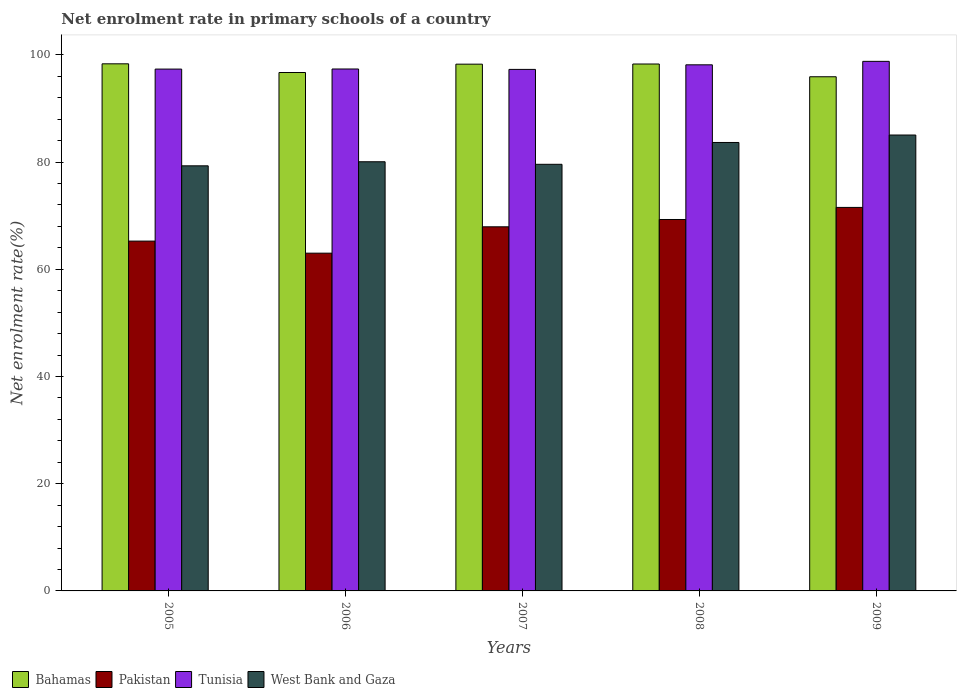How many different coloured bars are there?
Your answer should be very brief. 4. Are the number of bars per tick equal to the number of legend labels?
Offer a very short reply. Yes. How many bars are there on the 1st tick from the left?
Provide a succinct answer. 4. In how many cases, is the number of bars for a given year not equal to the number of legend labels?
Your answer should be compact. 0. What is the net enrolment rate in primary schools in Pakistan in 2005?
Offer a very short reply. 65.26. Across all years, what is the maximum net enrolment rate in primary schools in Bahamas?
Make the answer very short. 98.34. Across all years, what is the minimum net enrolment rate in primary schools in Pakistan?
Your response must be concise. 63.01. In which year was the net enrolment rate in primary schools in Pakistan minimum?
Provide a succinct answer. 2006. What is the total net enrolment rate in primary schools in Pakistan in the graph?
Make the answer very short. 337.05. What is the difference between the net enrolment rate in primary schools in West Bank and Gaza in 2006 and that in 2008?
Your answer should be very brief. -3.6. What is the difference between the net enrolment rate in primary schools in Pakistan in 2009 and the net enrolment rate in primary schools in West Bank and Gaza in 2006?
Your response must be concise. -8.52. What is the average net enrolment rate in primary schools in Bahamas per year?
Provide a succinct answer. 97.51. In the year 2008, what is the difference between the net enrolment rate in primary schools in West Bank and Gaza and net enrolment rate in primary schools in Tunisia?
Provide a short and direct response. -14.49. In how many years, is the net enrolment rate in primary schools in Pakistan greater than 24 %?
Your answer should be compact. 5. What is the ratio of the net enrolment rate in primary schools in Tunisia in 2005 to that in 2009?
Offer a very short reply. 0.99. What is the difference between the highest and the second highest net enrolment rate in primary schools in Pakistan?
Your response must be concise. 2.25. What is the difference between the highest and the lowest net enrolment rate in primary schools in West Bank and Gaza?
Your response must be concise. 5.75. In how many years, is the net enrolment rate in primary schools in West Bank and Gaza greater than the average net enrolment rate in primary schools in West Bank and Gaza taken over all years?
Provide a short and direct response. 2. Is the sum of the net enrolment rate in primary schools in Pakistan in 2006 and 2008 greater than the maximum net enrolment rate in primary schools in Tunisia across all years?
Your answer should be very brief. Yes. Is it the case that in every year, the sum of the net enrolment rate in primary schools in Tunisia and net enrolment rate in primary schools in Bahamas is greater than the sum of net enrolment rate in primary schools in West Bank and Gaza and net enrolment rate in primary schools in Pakistan?
Your response must be concise. No. What does the 3rd bar from the left in 2005 represents?
Your answer should be very brief. Tunisia. What does the 1st bar from the right in 2009 represents?
Give a very brief answer. West Bank and Gaza. Is it the case that in every year, the sum of the net enrolment rate in primary schools in Pakistan and net enrolment rate in primary schools in Bahamas is greater than the net enrolment rate in primary schools in Tunisia?
Your answer should be compact. Yes. How many years are there in the graph?
Your answer should be very brief. 5. Are the values on the major ticks of Y-axis written in scientific E-notation?
Keep it short and to the point. No. Does the graph contain any zero values?
Provide a short and direct response. No. What is the title of the graph?
Provide a succinct answer. Net enrolment rate in primary schools of a country. Does "Bulgaria" appear as one of the legend labels in the graph?
Your response must be concise. No. What is the label or title of the Y-axis?
Your answer should be compact. Net enrolment rate(%). What is the Net enrolment rate(%) in Bahamas in 2005?
Your answer should be compact. 98.34. What is the Net enrolment rate(%) of Pakistan in 2005?
Provide a succinct answer. 65.26. What is the Net enrolment rate(%) in Tunisia in 2005?
Your answer should be compact. 97.35. What is the Net enrolment rate(%) in West Bank and Gaza in 2005?
Give a very brief answer. 79.31. What is the Net enrolment rate(%) in Bahamas in 2006?
Give a very brief answer. 96.72. What is the Net enrolment rate(%) in Pakistan in 2006?
Your answer should be compact. 63.01. What is the Net enrolment rate(%) of Tunisia in 2006?
Your response must be concise. 97.37. What is the Net enrolment rate(%) in West Bank and Gaza in 2006?
Your answer should be compact. 80.07. What is the Net enrolment rate(%) in Bahamas in 2007?
Make the answer very short. 98.27. What is the Net enrolment rate(%) in Pakistan in 2007?
Your answer should be compact. 67.93. What is the Net enrolment rate(%) in Tunisia in 2007?
Provide a succinct answer. 97.3. What is the Net enrolment rate(%) in West Bank and Gaza in 2007?
Make the answer very short. 79.59. What is the Net enrolment rate(%) in Bahamas in 2008?
Make the answer very short. 98.3. What is the Net enrolment rate(%) in Pakistan in 2008?
Give a very brief answer. 69.29. What is the Net enrolment rate(%) of Tunisia in 2008?
Your answer should be compact. 98.15. What is the Net enrolment rate(%) in West Bank and Gaza in 2008?
Give a very brief answer. 83.66. What is the Net enrolment rate(%) in Bahamas in 2009?
Provide a succinct answer. 95.92. What is the Net enrolment rate(%) in Pakistan in 2009?
Provide a succinct answer. 71.55. What is the Net enrolment rate(%) of Tunisia in 2009?
Your response must be concise. 98.8. What is the Net enrolment rate(%) in West Bank and Gaza in 2009?
Make the answer very short. 85.05. Across all years, what is the maximum Net enrolment rate(%) of Bahamas?
Offer a terse response. 98.34. Across all years, what is the maximum Net enrolment rate(%) in Pakistan?
Make the answer very short. 71.55. Across all years, what is the maximum Net enrolment rate(%) in Tunisia?
Your answer should be compact. 98.8. Across all years, what is the maximum Net enrolment rate(%) of West Bank and Gaza?
Provide a succinct answer. 85.05. Across all years, what is the minimum Net enrolment rate(%) in Bahamas?
Your answer should be compact. 95.92. Across all years, what is the minimum Net enrolment rate(%) in Pakistan?
Offer a very short reply. 63.01. Across all years, what is the minimum Net enrolment rate(%) of Tunisia?
Your response must be concise. 97.3. Across all years, what is the minimum Net enrolment rate(%) of West Bank and Gaza?
Provide a succinct answer. 79.31. What is the total Net enrolment rate(%) of Bahamas in the graph?
Provide a succinct answer. 487.55. What is the total Net enrolment rate(%) in Pakistan in the graph?
Your response must be concise. 337.05. What is the total Net enrolment rate(%) in Tunisia in the graph?
Ensure brevity in your answer.  488.97. What is the total Net enrolment rate(%) of West Bank and Gaza in the graph?
Provide a short and direct response. 407.68. What is the difference between the Net enrolment rate(%) in Bahamas in 2005 and that in 2006?
Make the answer very short. 1.62. What is the difference between the Net enrolment rate(%) of Pakistan in 2005 and that in 2006?
Offer a very short reply. 2.25. What is the difference between the Net enrolment rate(%) in Tunisia in 2005 and that in 2006?
Give a very brief answer. -0.02. What is the difference between the Net enrolment rate(%) in West Bank and Gaza in 2005 and that in 2006?
Provide a short and direct response. -0.76. What is the difference between the Net enrolment rate(%) in Bahamas in 2005 and that in 2007?
Offer a terse response. 0.06. What is the difference between the Net enrolment rate(%) of Pakistan in 2005 and that in 2007?
Your answer should be very brief. -2.67. What is the difference between the Net enrolment rate(%) of Tunisia in 2005 and that in 2007?
Your answer should be very brief. 0.06. What is the difference between the Net enrolment rate(%) in West Bank and Gaza in 2005 and that in 2007?
Keep it short and to the point. -0.28. What is the difference between the Net enrolment rate(%) of Bahamas in 2005 and that in 2008?
Your response must be concise. 0.04. What is the difference between the Net enrolment rate(%) of Pakistan in 2005 and that in 2008?
Ensure brevity in your answer.  -4.03. What is the difference between the Net enrolment rate(%) of Tunisia in 2005 and that in 2008?
Your response must be concise. -0.8. What is the difference between the Net enrolment rate(%) in West Bank and Gaza in 2005 and that in 2008?
Provide a succinct answer. -4.36. What is the difference between the Net enrolment rate(%) in Bahamas in 2005 and that in 2009?
Keep it short and to the point. 2.41. What is the difference between the Net enrolment rate(%) of Pakistan in 2005 and that in 2009?
Offer a very short reply. -6.28. What is the difference between the Net enrolment rate(%) in Tunisia in 2005 and that in 2009?
Offer a terse response. -1.44. What is the difference between the Net enrolment rate(%) in West Bank and Gaza in 2005 and that in 2009?
Offer a very short reply. -5.75. What is the difference between the Net enrolment rate(%) in Bahamas in 2006 and that in 2007?
Offer a very short reply. -1.56. What is the difference between the Net enrolment rate(%) in Pakistan in 2006 and that in 2007?
Provide a short and direct response. -4.92. What is the difference between the Net enrolment rate(%) in Tunisia in 2006 and that in 2007?
Give a very brief answer. 0.08. What is the difference between the Net enrolment rate(%) in West Bank and Gaza in 2006 and that in 2007?
Provide a succinct answer. 0.48. What is the difference between the Net enrolment rate(%) in Bahamas in 2006 and that in 2008?
Offer a terse response. -1.58. What is the difference between the Net enrolment rate(%) of Pakistan in 2006 and that in 2008?
Provide a succinct answer. -6.28. What is the difference between the Net enrolment rate(%) in Tunisia in 2006 and that in 2008?
Keep it short and to the point. -0.78. What is the difference between the Net enrolment rate(%) of West Bank and Gaza in 2006 and that in 2008?
Keep it short and to the point. -3.6. What is the difference between the Net enrolment rate(%) in Bahamas in 2006 and that in 2009?
Offer a terse response. 0.79. What is the difference between the Net enrolment rate(%) in Pakistan in 2006 and that in 2009?
Your answer should be very brief. -8.53. What is the difference between the Net enrolment rate(%) in Tunisia in 2006 and that in 2009?
Your answer should be compact. -1.42. What is the difference between the Net enrolment rate(%) in West Bank and Gaza in 2006 and that in 2009?
Provide a short and direct response. -4.99. What is the difference between the Net enrolment rate(%) of Bahamas in 2007 and that in 2008?
Offer a terse response. -0.03. What is the difference between the Net enrolment rate(%) of Pakistan in 2007 and that in 2008?
Your response must be concise. -1.36. What is the difference between the Net enrolment rate(%) in Tunisia in 2007 and that in 2008?
Provide a succinct answer. -0.86. What is the difference between the Net enrolment rate(%) of West Bank and Gaza in 2007 and that in 2008?
Give a very brief answer. -4.07. What is the difference between the Net enrolment rate(%) in Bahamas in 2007 and that in 2009?
Provide a succinct answer. 2.35. What is the difference between the Net enrolment rate(%) of Pakistan in 2007 and that in 2009?
Make the answer very short. -3.62. What is the difference between the Net enrolment rate(%) in Tunisia in 2007 and that in 2009?
Provide a succinct answer. -1.5. What is the difference between the Net enrolment rate(%) of West Bank and Gaza in 2007 and that in 2009?
Make the answer very short. -5.46. What is the difference between the Net enrolment rate(%) of Bahamas in 2008 and that in 2009?
Give a very brief answer. 2.38. What is the difference between the Net enrolment rate(%) of Pakistan in 2008 and that in 2009?
Your response must be concise. -2.25. What is the difference between the Net enrolment rate(%) in Tunisia in 2008 and that in 2009?
Give a very brief answer. -0.65. What is the difference between the Net enrolment rate(%) in West Bank and Gaza in 2008 and that in 2009?
Provide a short and direct response. -1.39. What is the difference between the Net enrolment rate(%) in Bahamas in 2005 and the Net enrolment rate(%) in Pakistan in 2006?
Provide a succinct answer. 35.32. What is the difference between the Net enrolment rate(%) of Bahamas in 2005 and the Net enrolment rate(%) of Tunisia in 2006?
Ensure brevity in your answer.  0.96. What is the difference between the Net enrolment rate(%) in Bahamas in 2005 and the Net enrolment rate(%) in West Bank and Gaza in 2006?
Your answer should be compact. 18.27. What is the difference between the Net enrolment rate(%) in Pakistan in 2005 and the Net enrolment rate(%) in Tunisia in 2006?
Give a very brief answer. -32.11. What is the difference between the Net enrolment rate(%) of Pakistan in 2005 and the Net enrolment rate(%) of West Bank and Gaza in 2006?
Give a very brief answer. -14.8. What is the difference between the Net enrolment rate(%) of Tunisia in 2005 and the Net enrolment rate(%) of West Bank and Gaza in 2006?
Your response must be concise. 17.29. What is the difference between the Net enrolment rate(%) of Bahamas in 2005 and the Net enrolment rate(%) of Pakistan in 2007?
Ensure brevity in your answer.  30.41. What is the difference between the Net enrolment rate(%) in Bahamas in 2005 and the Net enrolment rate(%) in Tunisia in 2007?
Your response must be concise. 1.04. What is the difference between the Net enrolment rate(%) of Bahamas in 2005 and the Net enrolment rate(%) of West Bank and Gaza in 2007?
Offer a terse response. 18.75. What is the difference between the Net enrolment rate(%) in Pakistan in 2005 and the Net enrolment rate(%) in Tunisia in 2007?
Ensure brevity in your answer.  -32.03. What is the difference between the Net enrolment rate(%) of Pakistan in 2005 and the Net enrolment rate(%) of West Bank and Gaza in 2007?
Ensure brevity in your answer.  -14.33. What is the difference between the Net enrolment rate(%) of Tunisia in 2005 and the Net enrolment rate(%) of West Bank and Gaza in 2007?
Your answer should be very brief. 17.76. What is the difference between the Net enrolment rate(%) in Bahamas in 2005 and the Net enrolment rate(%) in Pakistan in 2008?
Your answer should be compact. 29.04. What is the difference between the Net enrolment rate(%) in Bahamas in 2005 and the Net enrolment rate(%) in Tunisia in 2008?
Your answer should be very brief. 0.19. What is the difference between the Net enrolment rate(%) of Bahamas in 2005 and the Net enrolment rate(%) of West Bank and Gaza in 2008?
Your answer should be compact. 14.68. What is the difference between the Net enrolment rate(%) in Pakistan in 2005 and the Net enrolment rate(%) in Tunisia in 2008?
Make the answer very short. -32.89. What is the difference between the Net enrolment rate(%) of Pakistan in 2005 and the Net enrolment rate(%) of West Bank and Gaza in 2008?
Offer a very short reply. -18.4. What is the difference between the Net enrolment rate(%) in Tunisia in 2005 and the Net enrolment rate(%) in West Bank and Gaza in 2008?
Keep it short and to the point. 13.69. What is the difference between the Net enrolment rate(%) of Bahamas in 2005 and the Net enrolment rate(%) of Pakistan in 2009?
Make the answer very short. 26.79. What is the difference between the Net enrolment rate(%) in Bahamas in 2005 and the Net enrolment rate(%) in Tunisia in 2009?
Your answer should be compact. -0.46. What is the difference between the Net enrolment rate(%) of Bahamas in 2005 and the Net enrolment rate(%) of West Bank and Gaza in 2009?
Ensure brevity in your answer.  13.28. What is the difference between the Net enrolment rate(%) in Pakistan in 2005 and the Net enrolment rate(%) in Tunisia in 2009?
Give a very brief answer. -33.53. What is the difference between the Net enrolment rate(%) of Pakistan in 2005 and the Net enrolment rate(%) of West Bank and Gaza in 2009?
Provide a succinct answer. -19.79. What is the difference between the Net enrolment rate(%) of Tunisia in 2005 and the Net enrolment rate(%) of West Bank and Gaza in 2009?
Ensure brevity in your answer.  12.3. What is the difference between the Net enrolment rate(%) of Bahamas in 2006 and the Net enrolment rate(%) of Pakistan in 2007?
Your answer should be very brief. 28.79. What is the difference between the Net enrolment rate(%) in Bahamas in 2006 and the Net enrolment rate(%) in Tunisia in 2007?
Give a very brief answer. -0.58. What is the difference between the Net enrolment rate(%) in Bahamas in 2006 and the Net enrolment rate(%) in West Bank and Gaza in 2007?
Your answer should be compact. 17.13. What is the difference between the Net enrolment rate(%) of Pakistan in 2006 and the Net enrolment rate(%) of Tunisia in 2007?
Keep it short and to the point. -34.28. What is the difference between the Net enrolment rate(%) of Pakistan in 2006 and the Net enrolment rate(%) of West Bank and Gaza in 2007?
Provide a short and direct response. -16.58. What is the difference between the Net enrolment rate(%) in Tunisia in 2006 and the Net enrolment rate(%) in West Bank and Gaza in 2007?
Offer a very short reply. 17.78. What is the difference between the Net enrolment rate(%) of Bahamas in 2006 and the Net enrolment rate(%) of Pakistan in 2008?
Provide a succinct answer. 27.42. What is the difference between the Net enrolment rate(%) of Bahamas in 2006 and the Net enrolment rate(%) of Tunisia in 2008?
Your response must be concise. -1.43. What is the difference between the Net enrolment rate(%) in Bahamas in 2006 and the Net enrolment rate(%) in West Bank and Gaza in 2008?
Give a very brief answer. 13.05. What is the difference between the Net enrolment rate(%) in Pakistan in 2006 and the Net enrolment rate(%) in Tunisia in 2008?
Provide a short and direct response. -35.14. What is the difference between the Net enrolment rate(%) of Pakistan in 2006 and the Net enrolment rate(%) of West Bank and Gaza in 2008?
Ensure brevity in your answer.  -20.65. What is the difference between the Net enrolment rate(%) in Tunisia in 2006 and the Net enrolment rate(%) in West Bank and Gaza in 2008?
Offer a terse response. 13.71. What is the difference between the Net enrolment rate(%) in Bahamas in 2006 and the Net enrolment rate(%) in Pakistan in 2009?
Make the answer very short. 25.17. What is the difference between the Net enrolment rate(%) of Bahamas in 2006 and the Net enrolment rate(%) of Tunisia in 2009?
Your answer should be compact. -2.08. What is the difference between the Net enrolment rate(%) of Bahamas in 2006 and the Net enrolment rate(%) of West Bank and Gaza in 2009?
Ensure brevity in your answer.  11.66. What is the difference between the Net enrolment rate(%) of Pakistan in 2006 and the Net enrolment rate(%) of Tunisia in 2009?
Provide a succinct answer. -35.78. What is the difference between the Net enrolment rate(%) in Pakistan in 2006 and the Net enrolment rate(%) in West Bank and Gaza in 2009?
Ensure brevity in your answer.  -22.04. What is the difference between the Net enrolment rate(%) in Tunisia in 2006 and the Net enrolment rate(%) in West Bank and Gaza in 2009?
Make the answer very short. 12.32. What is the difference between the Net enrolment rate(%) in Bahamas in 2007 and the Net enrolment rate(%) in Pakistan in 2008?
Offer a very short reply. 28.98. What is the difference between the Net enrolment rate(%) of Bahamas in 2007 and the Net enrolment rate(%) of Tunisia in 2008?
Provide a succinct answer. 0.12. What is the difference between the Net enrolment rate(%) of Bahamas in 2007 and the Net enrolment rate(%) of West Bank and Gaza in 2008?
Ensure brevity in your answer.  14.61. What is the difference between the Net enrolment rate(%) of Pakistan in 2007 and the Net enrolment rate(%) of Tunisia in 2008?
Your answer should be very brief. -30.22. What is the difference between the Net enrolment rate(%) in Pakistan in 2007 and the Net enrolment rate(%) in West Bank and Gaza in 2008?
Make the answer very short. -15.73. What is the difference between the Net enrolment rate(%) in Tunisia in 2007 and the Net enrolment rate(%) in West Bank and Gaza in 2008?
Your response must be concise. 13.63. What is the difference between the Net enrolment rate(%) of Bahamas in 2007 and the Net enrolment rate(%) of Pakistan in 2009?
Ensure brevity in your answer.  26.73. What is the difference between the Net enrolment rate(%) of Bahamas in 2007 and the Net enrolment rate(%) of Tunisia in 2009?
Provide a short and direct response. -0.52. What is the difference between the Net enrolment rate(%) of Bahamas in 2007 and the Net enrolment rate(%) of West Bank and Gaza in 2009?
Your answer should be compact. 13.22. What is the difference between the Net enrolment rate(%) in Pakistan in 2007 and the Net enrolment rate(%) in Tunisia in 2009?
Offer a terse response. -30.87. What is the difference between the Net enrolment rate(%) in Pakistan in 2007 and the Net enrolment rate(%) in West Bank and Gaza in 2009?
Provide a short and direct response. -17.12. What is the difference between the Net enrolment rate(%) of Tunisia in 2007 and the Net enrolment rate(%) of West Bank and Gaza in 2009?
Offer a terse response. 12.24. What is the difference between the Net enrolment rate(%) in Bahamas in 2008 and the Net enrolment rate(%) in Pakistan in 2009?
Your answer should be compact. 26.75. What is the difference between the Net enrolment rate(%) in Bahamas in 2008 and the Net enrolment rate(%) in Tunisia in 2009?
Give a very brief answer. -0.5. What is the difference between the Net enrolment rate(%) in Bahamas in 2008 and the Net enrolment rate(%) in West Bank and Gaza in 2009?
Ensure brevity in your answer.  13.25. What is the difference between the Net enrolment rate(%) in Pakistan in 2008 and the Net enrolment rate(%) in Tunisia in 2009?
Your answer should be compact. -29.5. What is the difference between the Net enrolment rate(%) of Pakistan in 2008 and the Net enrolment rate(%) of West Bank and Gaza in 2009?
Keep it short and to the point. -15.76. What is the difference between the Net enrolment rate(%) of Tunisia in 2008 and the Net enrolment rate(%) of West Bank and Gaza in 2009?
Offer a terse response. 13.1. What is the average Net enrolment rate(%) of Bahamas per year?
Offer a very short reply. 97.51. What is the average Net enrolment rate(%) of Pakistan per year?
Ensure brevity in your answer.  67.41. What is the average Net enrolment rate(%) in Tunisia per year?
Offer a very short reply. 97.79. What is the average Net enrolment rate(%) in West Bank and Gaza per year?
Give a very brief answer. 81.54. In the year 2005, what is the difference between the Net enrolment rate(%) in Bahamas and Net enrolment rate(%) in Pakistan?
Your answer should be compact. 33.07. In the year 2005, what is the difference between the Net enrolment rate(%) of Bahamas and Net enrolment rate(%) of Tunisia?
Your answer should be very brief. 0.98. In the year 2005, what is the difference between the Net enrolment rate(%) of Bahamas and Net enrolment rate(%) of West Bank and Gaza?
Make the answer very short. 19.03. In the year 2005, what is the difference between the Net enrolment rate(%) in Pakistan and Net enrolment rate(%) in Tunisia?
Keep it short and to the point. -32.09. In the year 2005, what is the difference between the Net enrolment rate(%) in Pakistan and Net enrolment rate(%) in West Bank and Gaza?
Your answer should be very brief. -14.04. In the year 2005, what is the difference between the Net enrolment rate(%) of Tunisia and Net enrolment rate(%) of West Bank and Gaza?
Provide a short and direct response. 18.05. In the year 2006, what is the difference between the Net enrolment rate(%) in Bahamas and Net enrolment rate(%) in Pakistan?
Offer a terse response. 33.7. In the year 2006, what is the difference between the Net enrolment rate(%) of Bahamas and Net enrolment rate(%) of Tunisia?
Make the answer very short. -0.66. In the year 2006, what is the difference between the Net enrolment rate(%) in Bahamas and Net enrolment rate(%) in West Bank and Gaza?
Provide a short and direct response. 16.65. In the year 2006, what is the difference between the Net enrolment rate(%) of Pakistan and Net enrolment rate(%) of Tunisia?
Your answer should be very brief. -34.36. In the year 2006, what is the difference between the Net enrolment rate(%) of Pakistan and Net enrolment rate(%) of West Bank and Gaza?
Your answer should be very brief. -17.05. In the year 2006, what is the difference between the Net enrolment rate(%) of Tunisia and Net enrolment rate(%) of West Bank and Gaza?
Offer a terse response. 17.31. In the year 2007, what is the difference between the Net enrolment rate(%) of Bahamas and Net enrolment rate(%) of Pakistan?
Offer a very short reply. 30.34. In the year 2007, what is the difference between the Net enrolment rate(%) of Bahamas and Net enrolment rate(%) of Tunisia?
Offer a very short reply. 0.98. In the year 2007, what is the difference between the Net enrolment rate(%) of Bahamas and Net enrolment rate(%) of West Bank and Gaza?
Make the answer very short. 18.68. In the year 2007, what is the difference between the Net enrolment rate(%) of Pakistan and Net enrolment rate(%) of Tunisia?
Your answer should be compact. -29.36. In the year 2007, what is the difference between the Net enrolment rate(%) of Pakistan and Net enrolment rate(%) of West Bank and Gaza?
Your answer should be compact. -11.66. In the year 2007, what is the difference between the Net enrolment rate(%) of Tunisia and Net enrolment rate(%) of West Bank and Gaza?
Make the answer very short. 17.7. In the year 2008, what is the difference between the Net enrolment rate(%) of Bahamas and Net enrolment rate(%) of Pakistan?
Your response must be concise. 29.01. In the year 2008, what is the difference between the Net enrolment rate(%) in Bahamas and Net enrolment rate(%) in Tunisia?
Your answer should be very brief. 0.15. In the year 2008, what is the difference between the Net enrolment rate(%) of Bahamas and Net enrolment rate(%) of West Bank and Gaza?
Provide a succinct answer. 14.64. In the year 2008, what is the difference between the Net enrolment rate(%) in Pakistan and Net enrolment rate(%) in Tunisia?
Give a very brief answer. -28.86. In the year 2008, what is the difference between the Net enrolment rate(%) in Pakistan and Net enrolment rate(%) in West Bank and Gaza?
Keep it short and to the point. -14.37. In the year 2008, what is the difference between the Net enrolment rate(%) of Tunisia and Net enrolment rate(%) of West Bank and Gaza?
Make the answer very short. 14.49. In the year 2009, what is the difference between the Net enrolment rate(%) in Bahamas and Net enrolment rate(%) in Pakistan?
Keep it short and to the point. 24.38. In the year 2009, what is the difference between the Net enrolment rate(%) of Bahamas and Net enrolment rate(%) of Tunisia?
Provide a short and direct response. -2.87. In the year 2009, what is the difference between the Net enrolment rate(%) in Bahamas and Net enrolment rate(%) in West Bank and Gaza?
Your response must be concise. 10.87. In the year 2009, what is the difference between the Net enrolment rate(%) in Pakistan and Net enrolment rate(%) in Tunisia?
Your answer should be very brief. -27.25. In the year 2009, what is the difference between the Net enrolment rate(%) of Pakistan and Net enrolment rate(%) of West Bank and Gaza?
Your answer should be very brief. -13.51. In the year 2009, what is the difference between the Net enrolment rate(%) of Tunisia and Net enrolment rate(%) of West Bank and Gaza?
Give a very brief answer. 13.74. What is the ratio of the Net enrolment rate(%) of Bahamas in 2005 to that in 2006?
Make the answer very short. 1.02. What is the ratio of the Net enrolment rate(%) in Pakistan in 2005 to that in 2006?
Provide a succinct answer. 1.04. What is the ratio of the Net enrolment rate(%) of West Bank and Gaza in 2005 to that in 2006?
Your answer should be compact. 0.99. What is the ratio of the Net enrolment rate(%) of Pakistan in 2005 to that in 2007?
Make the answer very short. 0.96. What is the ratio of the Net enrolment rate(%) of West Bank and Gaza in 2005 to that in 2007?
Give a very brief answer. 1. What is the ratio of the Net enrolment rate(%) of Bahamas in 2005 to that in 2008?
Make the answer very short. 1. What is the ratio of the Net enrolment rate(%) in Pakistan in 2005 to that in 2008?
Your answer should be very brief. 0.94. What is the ratio of the Net enrolment rate(%) in Tunisia in 2005 to that in 2008?
Provide a succinct answer. 0.99. What is the ratio of the Net enrolment rate(%) in West Bank and Gaza in 2005 to that in 2008?
Your answer should be very brief. 0.95. What is the ratio of the Net enrolment rate(%) in Bahamas in 2005 to that in 2009?
Offer a terse response. 1.03. What is the ratio of the Net enrolment rate(%) of Pakistan in 2005 to that in 2009?
Provide a short and direct response. 0.91. What is the ratio of the Net enrolment rate(%) in Tunisia in 2005 to that in 2009?
Ensure brevity in your answer.  0.99. What is the ratio of the Net enrolment rate(%) in West Bank and Gaza in 2005 to that in 2009?
Your answer should be compact. 0.93. What is the ratio of the Net enrolment rate(%) of Bahamas in 2006 to that in 2007?
Your answer should be very brief. 0.98. What is the ratio of the Net enrolment rate(%) in Pakistan in 2006 to that in 2007?
Make the answer very short. 0.93. What is the ratio of the Net enrolment rate(%) of Bahamas in 2006 to that in 2008?
Your answer should be compact. 0.98. What is the ratio of the Net enrolment rate(%) in Pakistan in 2006 to that in 2008?
Ensure brevity in your answer.  0.91. What is the ratio of the Net enrolment rate(%) of Tunisia in 2006 to that in 2008?
Ensure brevity in your answer.  0.99. What is the ratio of the Net enrolment rate(%) in West Bank and Gaza in 2006 to that in 2008?
Your answer should be very brief. 0.96. What is the ratio of the Net enrolment rate(%) in Bahamas in 2006 to that in 2009?
Your answer should be compact. 1.01. What is the ratio of the Net enrolment rate(%) of Pakistan in 2006 to that in 2009?
Ensure brevity in your answer.  0.88. What is the ratio of the Net enrolment rate(%) in Tunisia in 2006 to that in 2009?
Ensure brevity in your answer.  0.99. What is the ratio of the Net enrolment rate(%) of West Bank and Gaza in 2006 to that in 2009?
Your answer should be compact. 0.94. What is the ratio of the Net enrolment rate(%) of Pakistan in 2007 to that in 2008?
Your answer should be compact. 0.98. What is the ratio of the Net enrolment rate(%) of West Bank and Gaza in 2007 to that in 2008?
Provide a succinct answer. 0.95. What is the ratio of the Net enrolment rate(%) of Bahamas in 2007 to that in 2009?
Keep it short and to the point. 1.02. What is the ratio of the Net enrolment rate(%) in Pakistan in 2007 to that in 2009?
Offer a very short reply. 0.95. What is the ratio of the Net enrolment rate(%) in Tunisia in 2007 to that in 2009?
Make the answer very short. 0.98. What is the ratio of the Net enrolment rate(%) of West Bank and Gaza in 2007 to that in 2009?
Keep it short and to the point. 0.94. What is the ratio of the Net enrolment rate(%) in Bahamas in 2008 to that in 2009?
Keep it short and to the point. 1.02. What is the ratio of the Net enrolment rate(%) of Pakistan in 2008 to that in 2009?
Offer a very short reply. 0.97. What is the ratio of the Net enrolment rate(%) in West Bank and Gaza in 2008 to that in 2009?
Offer a terse response. 0.98. What is the difference between the highest and the second highest Net enrolment rate(%) in Bahamas?
Provide a succinct answer. 0.04. What is the difference between the highest and the second highest Net enrolment rate(%) of Pakistan?
Make the answer very short. 2.25. What is the difference between the highest and the second highest Net enrolment rate(%) in Tunisia?
Make the answer very short. 0.65. What is the difference between the highest and the second highest Net enrolment rate(%) of West Bank and Gaza?
Your answer should be very brief. 1.39. What is the difference between the highest and the lowest Net enrolment rate(%) of Bahamas?
Provide a short and direct response. 2.41. What is the difference between the highest and the lowest Net enrolment rate(%) in Pakistan?
Your answer should be compact. 8.53. What is the difference between the highest and the lowest Net enrolment rate(%) of Tunisia?
Provide a succinct answer. 1.5. What is the difference between the highest and the lowest Net enrolment rate(%) of West Bank and Gaza?
Ensure brevity in your answer.  5.75. 